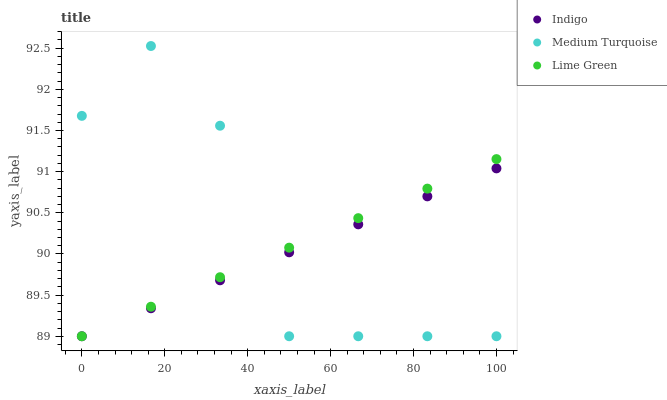Does Indigo have the minimum area under the curve?
Answer yes or no. Yes. Does Medium Turquoise have the maximum area under the curve?
Answer yes or no. Yes. Does Medium Turquoise have the minimum area under the curve?
Answer yes or no. No. Does Indigo have the maximum area under the curve?
Answer yes or no. No. Is Lime Green the smoothest?
Answer yes or no. Yes. Is Medium Turquoise the roughest?
Answer yes or no. Yes. Is Indigo the smoothest?
Answer yes or no. No. Is Indigo the roughest?
Answer yes or no. No. Does Lime Green have the lowest value?
Answer yes or no. Yes. Does Medium Turquoise have the highest value?
Answer yes or no. Yes. Does Indigo have the highest value?
Answer yes or no. No. Does Indigo intersect Lime Green?
Answer yes or no. Yes. Is Indigo less than Lime Green?
Answer yes or no. No. Is Indigo greater than Lime Green?
Answer yes or no. No. 